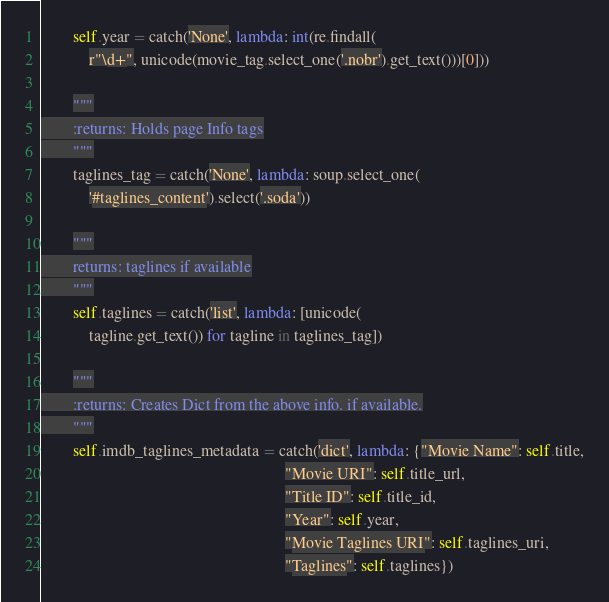<code> <loc_0><loc_0><loc_500><loc_500><_Python_>        self.year = catch('None', lambda: int(re.findall(
            r"\d+", unicode(movie_tag.select_one('.nobr').get_text()))[0]))

        """
        :returns: Holds page Info tags
        """
        taglines_tag = catch('None', lambda: soup.select_one(
            '#taglines_content').select('.soda'))

        """
        returns: taglines if available
        """
        self.taglines = catch('list', lambda: [unicode(
            tagline.get_text()) for tagline in taglines_tag])

        """
        :returns: Creates Dict from the above info. if available.
        """
        self.imdb_taglines_metadata = catch('dict', lambda: {"Movie Name": self.title,
                                                             "Movie URI": self.title_url,
                                                             "Title ID": self.title_id,
                                                             "Year": self.year,
                                                             "Movie Taglines URI": self.taglines_uri,
                                                             "Taglines": self.taglines})
</code> 